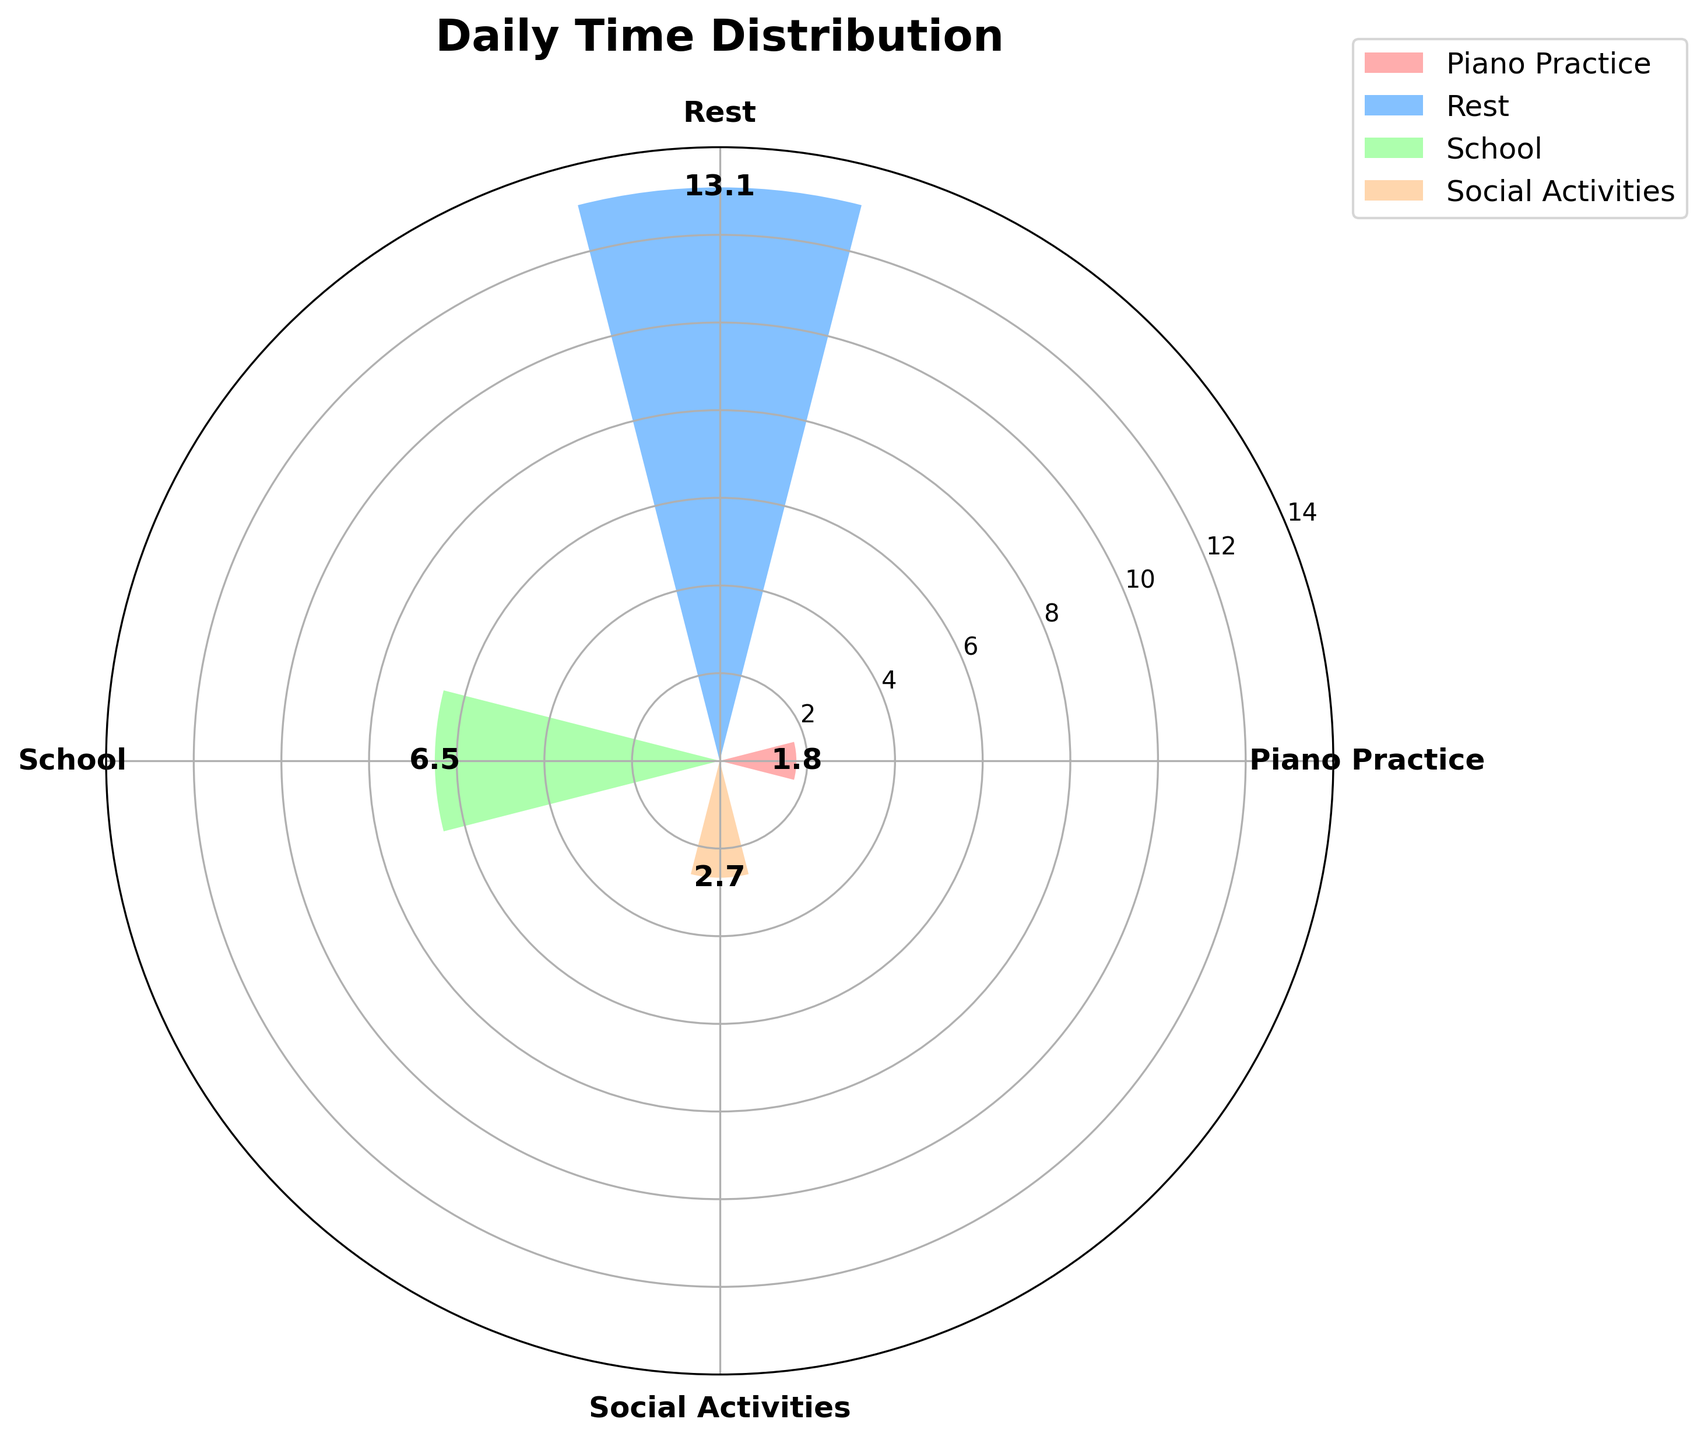What is the title of the figure? The title is at the top of the chart and clearly states the subject of the visualization.
Answer: Daily Time Distribution Which category has the highest average number of hours? From the visual heights of the bars, the category with the largest radius is the one with the highest average.
Answer: Rest How many categories are represented in the chart? Count the number of distinct bars or segments in the plot.
Answer: 4 What is the average number of hours spent on School activities? Locate the bar corresponding to 'School' and read the value indicated.
Answer: 6.5 How does the average time spent on Piano Practice compare to Social Activities? Compare the heights of the bars for 'Piano Practice' and 'Social Activities'.
Answer: Piano Practice averages less time than Social Activities What is the sum of the average hours spent on School and Rest? Add the average values of the 'School' and 'Rest' categories.
Answer: 6.5 + 13 = 19.5 Which category has the lowest average number of hours? Identify the bar with the smallest radius.
Answer: Piano Practice What is the range of the average hours for Social Activities? Calculate the difference between the maximum and minimum points of the 'Social Activities' bar.
Answer: 3 If you added 1 hour to the average time spent on Piano Practice, how would this compare to Social Activities? Add 1 to the average of 'Piano Practice' and then compare it to 'Social Activities'.
Answer: It would be equal 